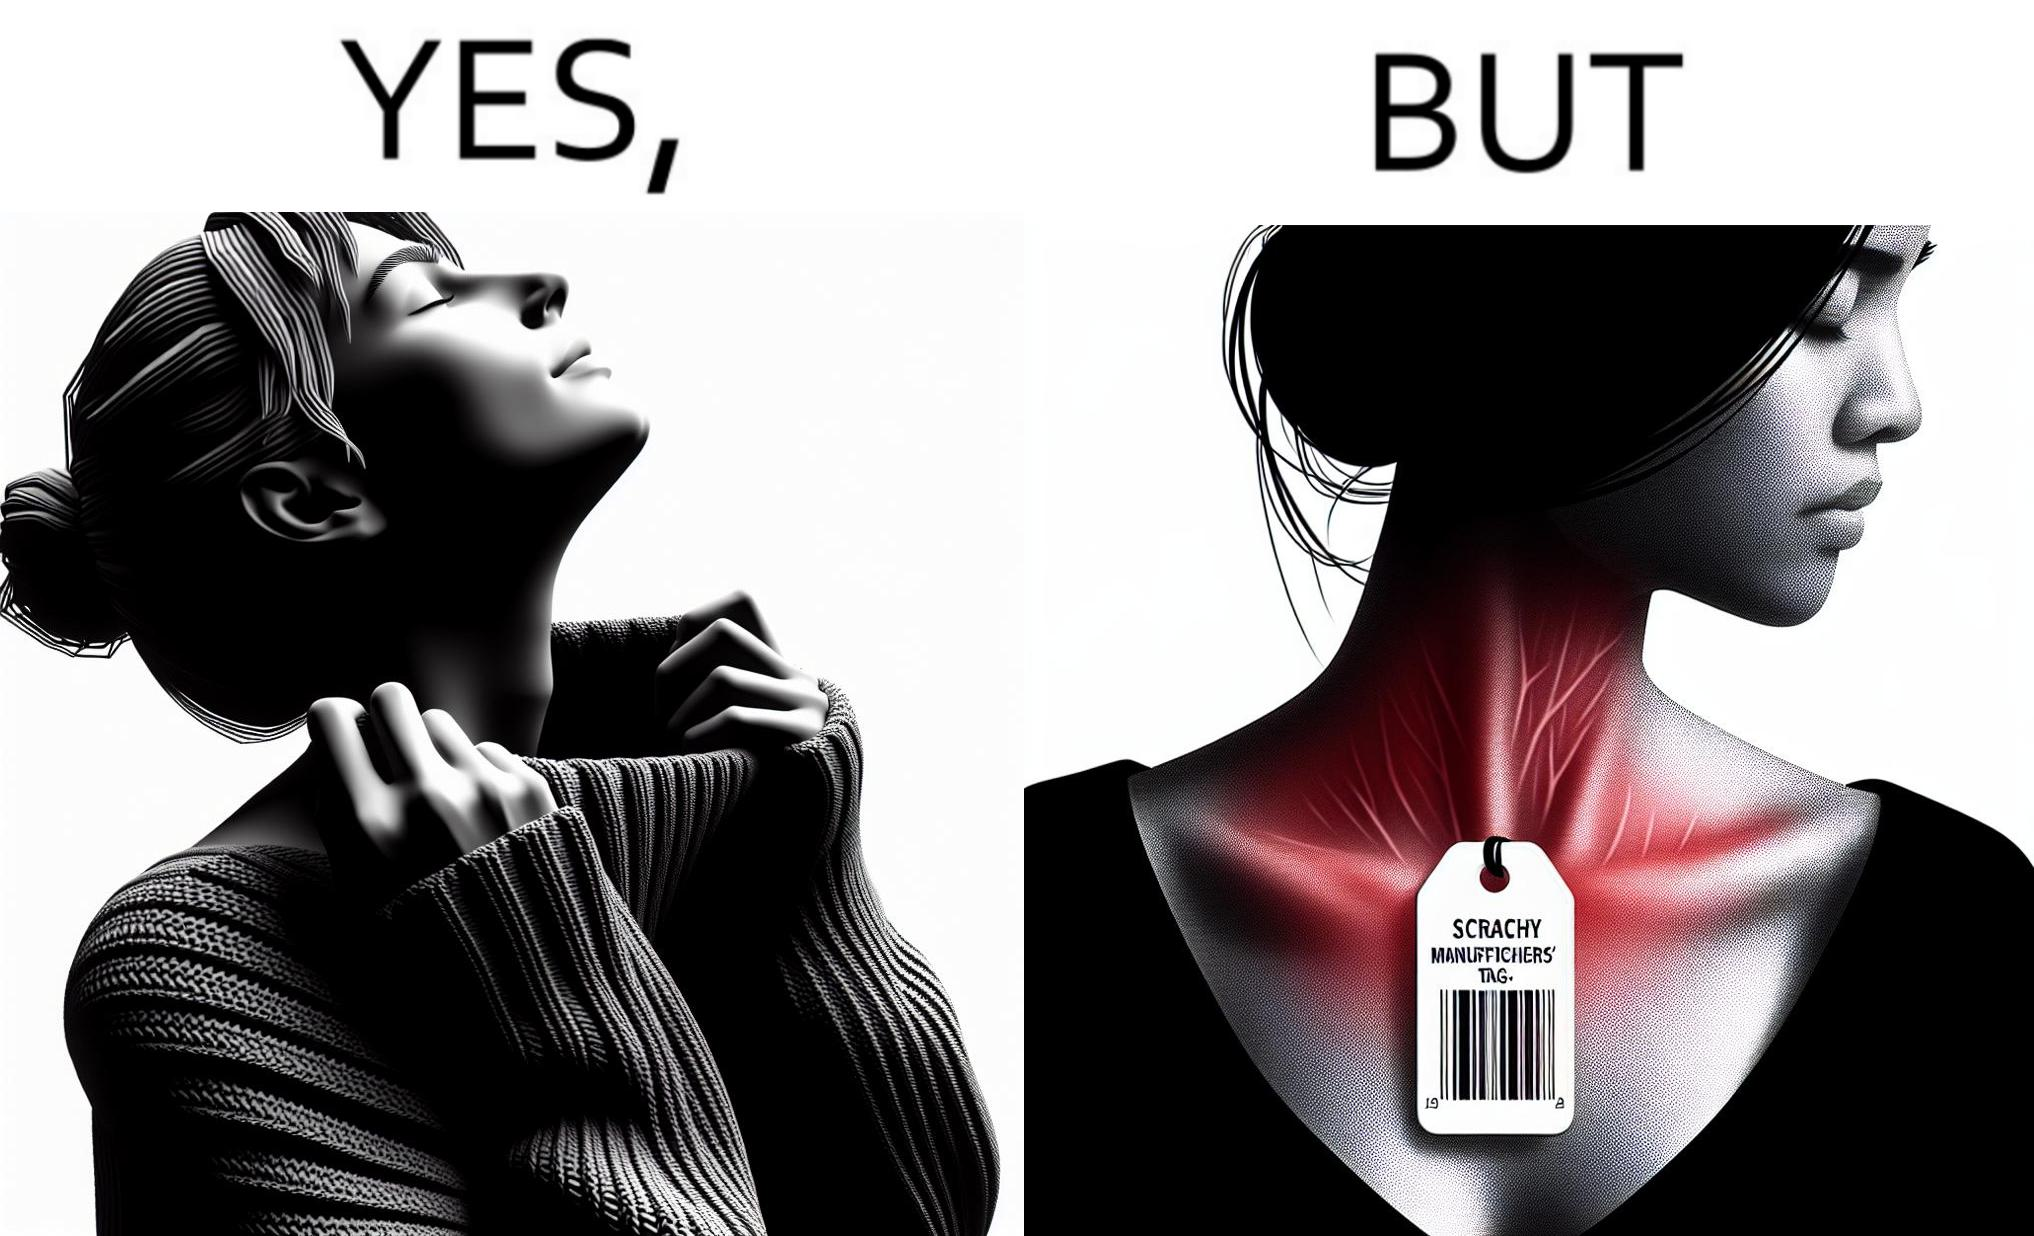Why is this image considered satirical? The images are funny since it shows how even though sweaters and other clothings provide much comfort, a tiny manufacturers tag ends up causing the user a lot of discomfort due to constant scratching 